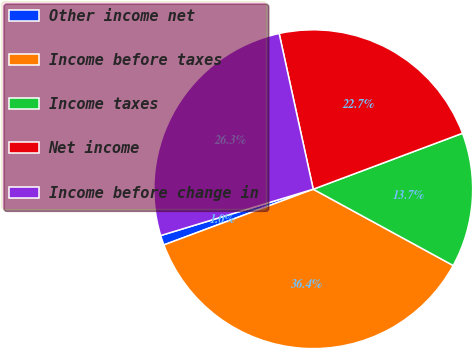Convert chart to OTSL. <chart><loc_0><loc_0><loc_500><loc_500><pie_chart><fcel>Other income net<fcel>Income before taxes<fcel>Income taxes<fcel>Net income<fcel>Income before change in<nl><fcel>0.99%<fcel>36.37%<fcel>13.65%<fcel>22.72%<fcel>26.26%<nl></chart> 